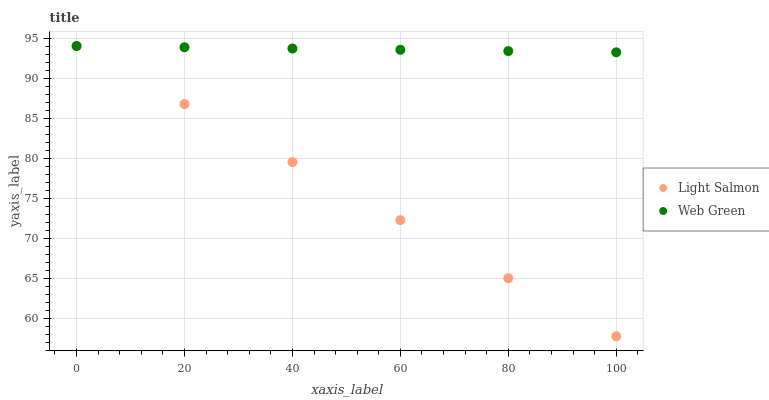Does Light Salmon have the minimum area under the curve?
Answer yes or no. Yes. Does Web Green have the maximum area under the curve?
Answer yes or no. Yes. Does Web Green have the minimum area under the curve?
Answer yes or no. No. Is Web Green the smoothest?
Answer yes or no. Yes. Is Light Salmon the roughest?
Answer yes or no. Yes. Is Web Green the roughest?
Answer yes or no. No. Does Light Salmon have the lowest value?
Answer yes or no. Yes. Does Web Green have the lowest value?
Answer yes or no. No. Does Web Green have the highest value?
Answer yes or no. Yes. Does Web Green intersect Light Salmon?
Answer yes or no. Yes. Is Web Green less than Light Salmon?
Answer yes or no. No. Is Web Green greater than Light Salmon?
Answer yes or no. No. 